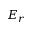<formula> <loc_0><loc_0><loc_500><loc_500>E _ { r }</formula> 